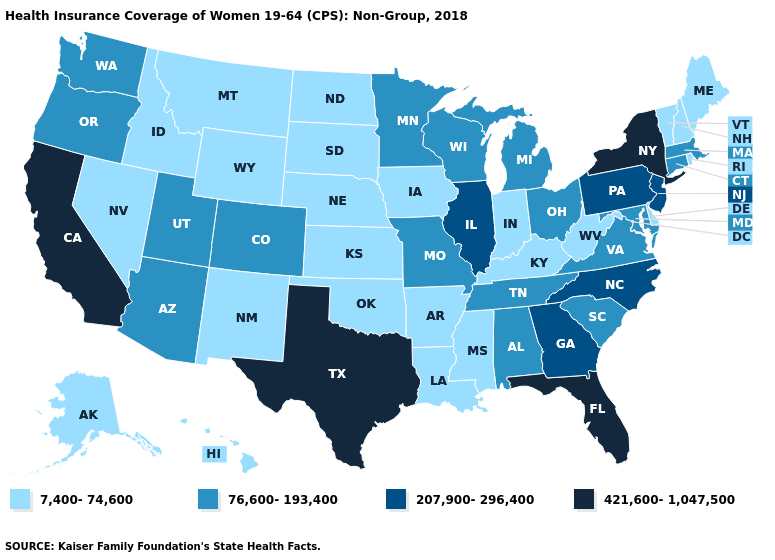What is the highest value in the USA?
Quick response, please. 421,600-1,047,500. What is the value of New Mexico?
Give a very brief answer. 7,400-74,600. Which states have the lowest value in the USA?
Be succinct. Alaska, Arkansas, Delaware, Hawaii, Idaho, Indiana, Iowa, Kansas, Kentucky, Louisiana, Maine, Mississippi, Montana, Nebraska, Nevada, New Hampshire, New Mexico, North Dakota, Oklahoma, Rhode Island, South Dakota, Vermont, West Virginia, Wyoming. Name the states that have a value in the range 7,400-74,600?
Concise answer only. Alaska, Arkansas, Delaware, Hawaii, Idaho, Indiana, Iowa, Kansas, Kentucky, Louisiana, Maine, Mississippi, Montana, Nebraska, Nevada, New Hampshire, New Mexico, North Dakota, Oklahoma, Rhode Island, South Dakota, Vermont, West Virginia, Wyoming. What is the value of New Jersey?
Concise answer only. 207,900-296,400. Is the legend a continuous bar?
Give a very brief answer. No. Does Illinois have the lowest value in the USA?
Answer briefly. No. What is the value of South Carolina?
Be succinct. 76,600-193,400. What is the value of Rhode Island?
Be succinct. 7,400-74,600. What is the highest value in the USA?
Be succinct. 421,600-1,047,500. Name the states that have a value in the range 76,600-193,400?
Write a very short answer. Alabama, Arizona, Colorado, Connecticut, Maryland, Massachusetts, Michigan, Minnesota, Missouri, Ohio, Oregon, South Carolina, Tennessee, Utah, Virginia, Washington, Wisconsin. Among the states that border Utah , does Nevada have the lowest value?
Concise answer only. Yes. What is the value of New Hampshire?
Short answer required. 7,400-74,600. What is the value of Tennessee?
Concise answer only. 76,600-193,400. Among the states that border Alabama , which have the highest value?
Short answer required. Florida. 